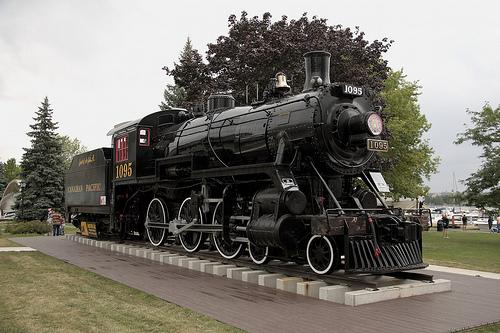Question: what type of transportation was shown?
Choices:
A. Truck.
B. Bus.
C. Car.
D. Train.
Answer with the letter. Answer: D Question: what is behind the train?
Choices:
A. Station.
B. Street.
C. Cars.
D. Trees.
Answer with the letter. Answer: D Question: what color is the platform the train is on?
Choices:
A. Gray.
B. Red.
C. White.
D. Brown.
Answer with the letter. Answer: A Question: what number is on the train?
Choices:
A. 1094.
B. 1093.
C. 1095.
D. 1096.
Answer with the letter. Answer: C Question: where is the bell?
Choices:
A. Next to the train driver.
B. Top of the train.
C. At the door.
D. Above the man.
Answer with the letter. Answer: B 